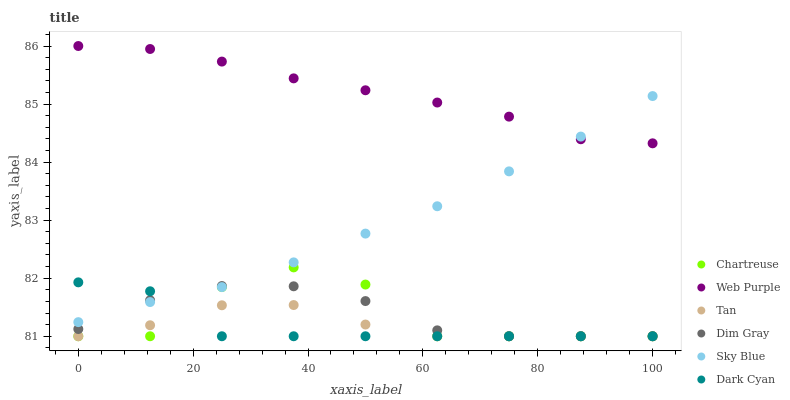Does Dark Cyan have the minimum area under the curve?
Answer yes or no. Yes. Does Web Purple have the maximum area under the curve?
Answer yes or no. Yes. Does Chartreuse have the minimum area under the curve?
Answer yes or no. No. Does Chartreuse have the maximum area under the curve?
Answer yes or no. No. Is Sky Blue the smoothest?
Answer yes or no. Yes. Is Chartreuse the roughest?
Answer yes or no. Yes. Is Web Purple the smoothest?
Answer yes or no. No. Is Web Purple the roughest?
Answer yes or no. No. Does Dim Gray have the lowest value?
Answer yes or no. Yes. Does Web Purple have the lowest value?
Answer yes or no. No. Does Web Purple have the highest value?
Answer yes or no. Yes. Does Chartreuse have the highest value?
Answer yes or no. No. Is Dark Cyan less than Web Purple?
Answer yes or no. Yes. Is Web Purple greater than Chartreuse?
Answer yes or no. Yes. Does Tan intersect Dim Gray?
Answer yes or no. Yes. Is Tan less than Dim Gray?
Answer yes or no. No. Is Tan greater than Dim Gray?
Answer yes or no. No. Does Dark Cyan intersect Web Purple?
Answer yes or no. No. 